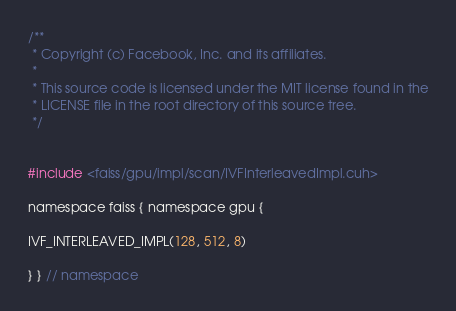<code> <loc_0><loc_0><loc_500><loc_500><_Cuda_>/**
 * Copyright (c) Facebook, Inc. and its affiliates.
 *
 * This source code is licensed under the MIT license found in the
 * LICENSE file in the root directory of this source tree.
 */


#include <faiss/gpu/impl/scan/IVFInterleavedImpl.cuh>

namespace faiss { namespace gpu {

IVF_INTERLEAVED_IMPL(128, 512, 8)

} } // namespace
</code> 